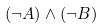Convert formula to latex. <formula><loc_0><loc_0><loc_500><loc_500>( \neg A ) \wedge ( \neg B )</formula> 